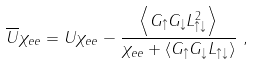Convert formula to latex. <formula><loc_0><loc_0><loc_500><loc_500>\overline { U } \chi _ { e e } & = U \chi _ { e e } - \frac { \left \langle G _ { \uparrow } G _ { \downarrow } L _ { \uparrow \downarrow } ^ { 2 } \right \rangle } { \chi _ { e e } + \left \langle G _ { \uparrow } G _ { \downarrow } L _ { \uparrow \downarrow } \right \rangle } \ ,</formula> 